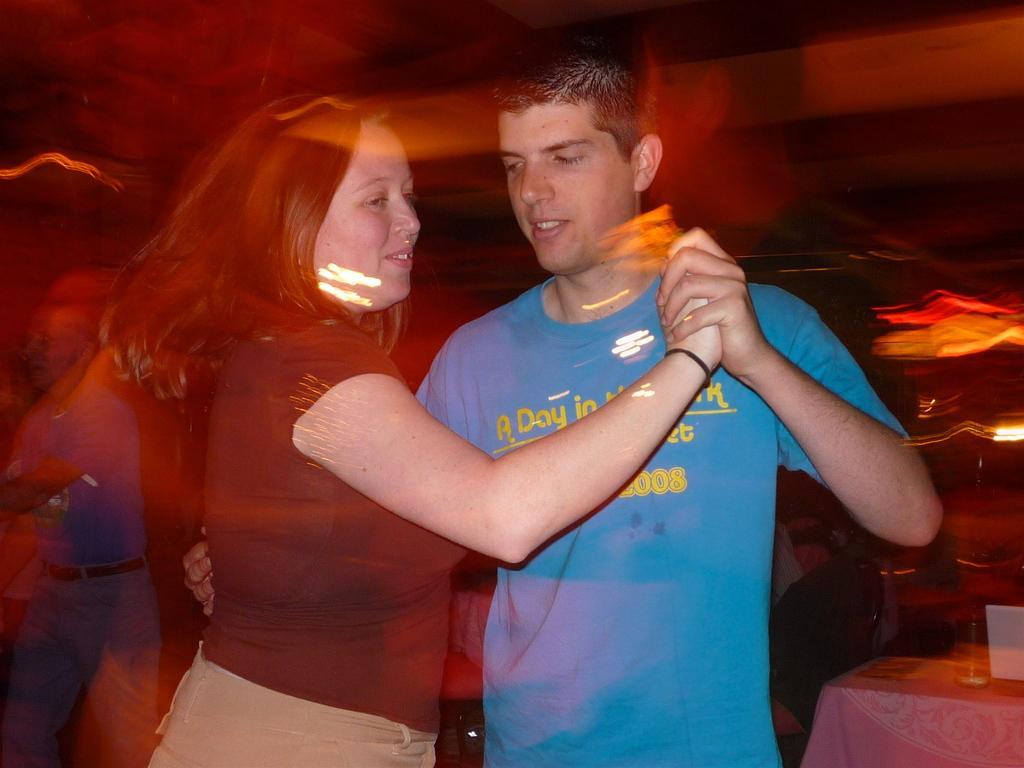Can you describe this image briefly? As we can see in the image in the front there are two people dancing. On the right side there is a table and the background is little blurred. 